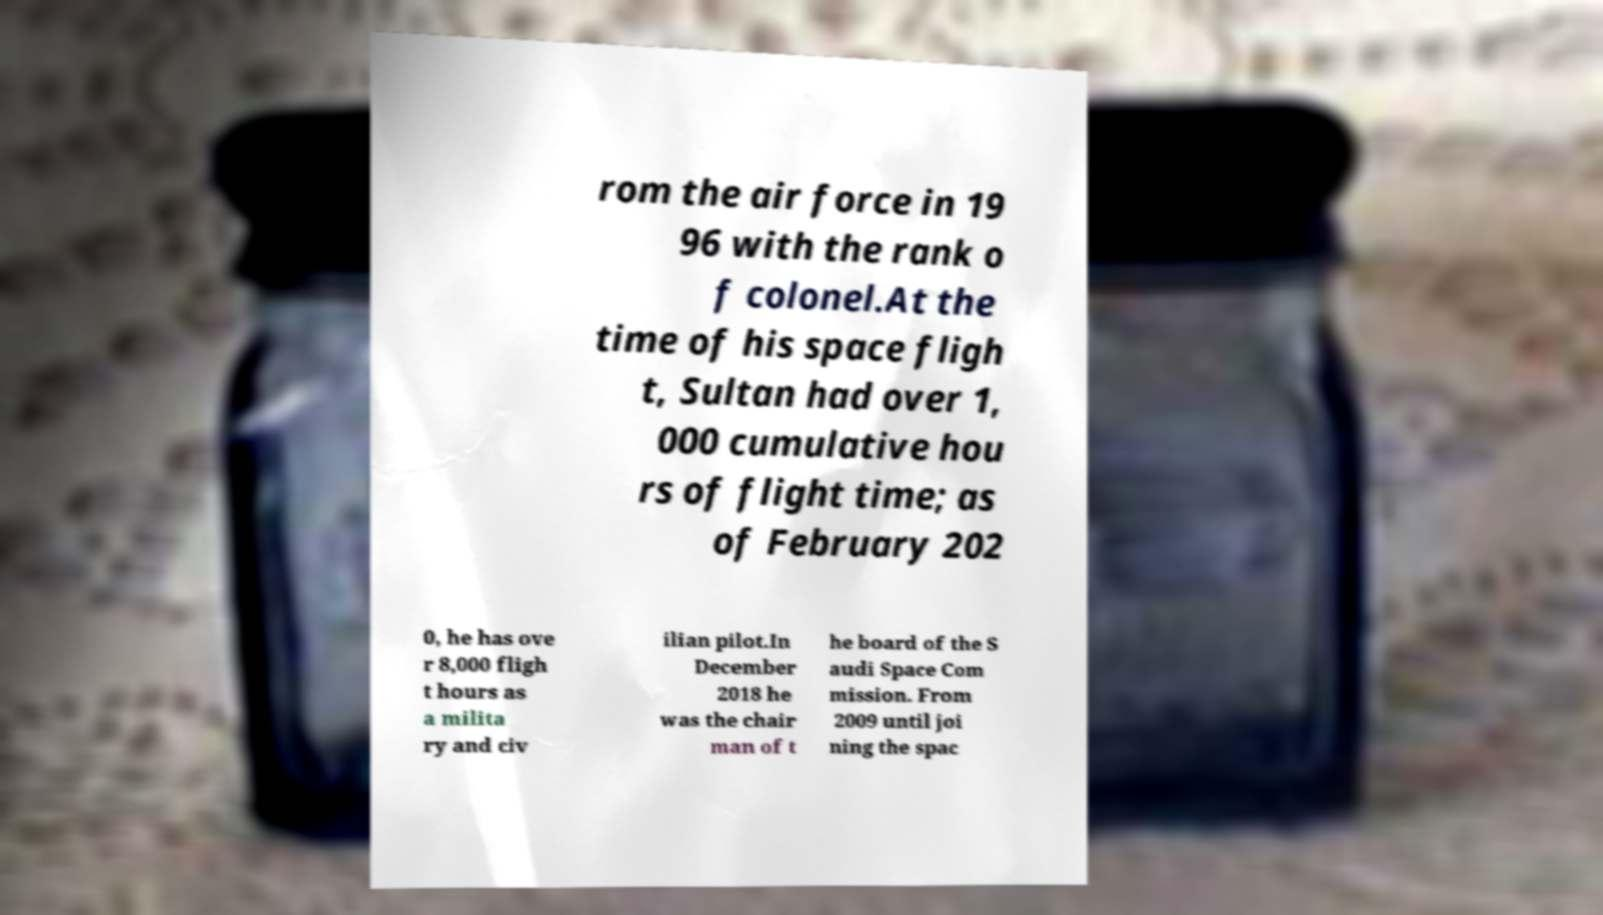Please identify and transcribe the text found in this image. rom the air force in 19 96 with the rank o f colonel.At the time of his space fligh t, Sultan had over 1, 000 cumulative hou rs of flight time; as of February 202 0, he has ove r 8,000 fligh t hours as a milita ry and civ ilian pilot.In December 2018 he was the chair man of t he board of the S audi Space Com mission. From 2009 until joi ning the spac 